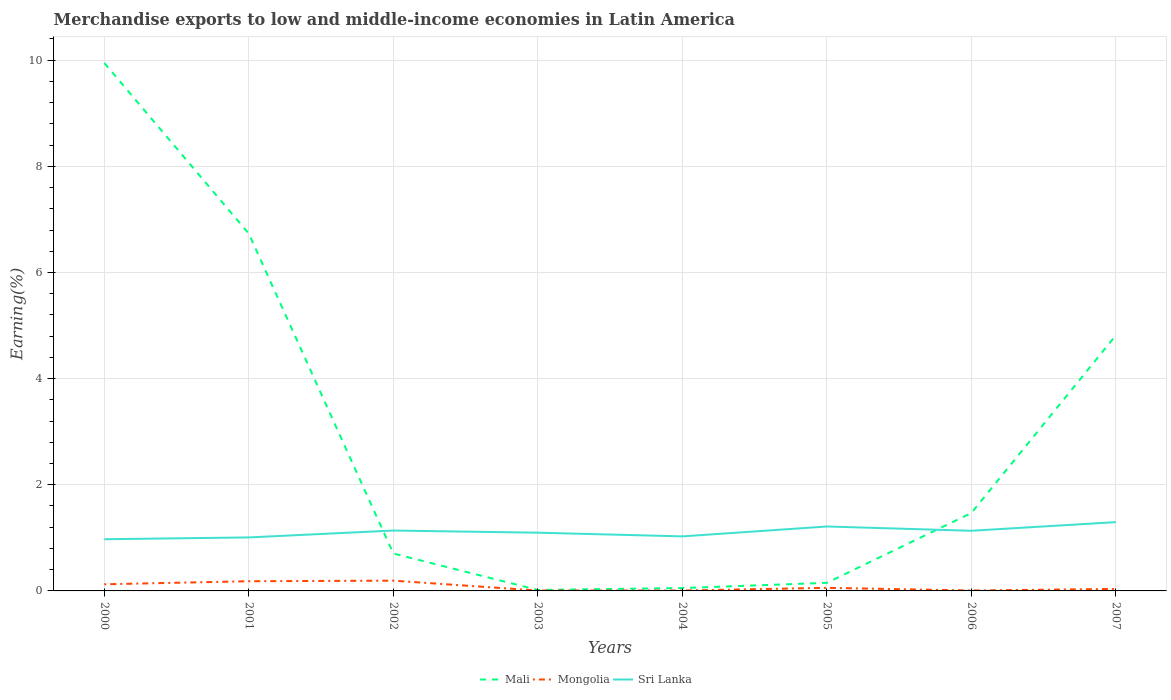How many different coloured lines are there?
Ensure brevity in your answer.  3. Does the line corresponding to Mali intersect with the line corresponding to Mongolia?
Provide a succinct answer. No. Is the number of lines equal to the number of legend labels?
Provide a succinct answer. Yes. Across all years, what is the maximum percentage of amount earned from merchandise exports in Sri Lanka?
Offer a terse response. 0.97. What is the total percentage of amount earned from merchandise exports in Mali in the graph?
Offer a very short reply. 3.22. What is the difference between the highest and the second highest percentage of amount earned from merchandise exports in Mongolia?
Provide a short and direct response. 0.19. Is the percentage of amount earned from merchandise exports in Mongolia strictly greater than the percentage of amount earned from merchandise exports in Sri Lanka over the years?
Your answer should be very brief. Yes. How many years are there in the graph?
Ensure brevity in your answer.  8. What is the difference between two consecutive major ticks on the Y-axis?
Provide a short and direct response. 2. Does the graph contain any zero values?
Give a very brief answer. No. How many legend labels are there?
Make the answer very short. 3. What is the title of the graph?
Your answer should be compact. Merchandise exports to low and middle-income economies in Latin America. What is the label or title of the Y-axis?
Offer a very short reply. Earning(%). What is the Earning(%) of Mali in 2000?
Provide a succinct answer. 9.95. What is the Earning(%) in Mongolia in 2000?
Your answer should be very brief. 0.13. What is the Earning(%) in Sri Lanka in 2000?
Your answer should be very brief. 0.97. What is the Earning(%) in Mali in 2001?
Your answer should be compact. 6.73. What is the Earning(%) in Mongolia in 2001?
Provide a short and direct response. 0.18. What is the Earning(%) of Sri Lanka in 2001?
Provide a short and direct response. 1.01. What is the Earning(%) of Mali in 2002?
Ensure brevity in your answer.  0.7. What is the Earning(%) of Mongolia in 2002?
Offer a very short reply. 0.19. What is the Earning(%) of Sri Lanka in 2002?
Your response must be concise. 1.14. What is the Earning(%) of Mali in 2003?
Provide a short and direct response. 0.02. What is the Earning(%) of Mongolia in 2003?
Offer a very short reply. 0.01. What is the Earning(%) of Sri Lanka in 2003?
Make the answer very short. 1.1. What is the Earning(%) in Mali in 2004?
Keep it short and to the point. 0.05. What is the Earning(%) in Mongolia in 2004?
Ensure brevity in your answer.  0.01. What is the Earning(%) of Sri Lanka in 2004?
Keep it short and to the point. 1.03. What is the Earning(%) of Mali in 2005?
Make the answer very short. 0.15. What is the Earning(%) of Mongolia in 2005?
Your answer should be very brief. 0.06. What is the Earning(%) of Sri Lanka in 2005?
Give a very brief answer. 1.21. What is the Earning(%) in Mali in 2006?
Keep it short and to the point. 1.47. What is the Earning(%) of Mongolia in 2006?
Your answer should be very brief. 0.01. What is the Earning(%) of Sri Lanka in 2006?
Give a very brief answer. 1.13. What is the Earning(%) of Mali in 2007?
Offer a terse response. 4.82. What is the Earning(%) in Mongolia in 2007?
Make the answer very short. 0.04. What is the Earning(%) of Sri Lanka in 2007?
Provide a succinct answer. 1.3. Across all years, what is the maximum Earning(%) in Mali?
Make the answer very short. 9.95. Across all years, what is the maximum Earning(%) of Mongolia?
Ensure brevity in your answer.  0.19. Across all years, what is the maximum Earning(%) in Sri Lanka?
Offer a very short reply. 1.3. Across all years, what is the minimum Earning(%) of Mali?
Your response must be concise. 0.02. Across all years, what is the minimum Earning(%) in Mongolia?
Your answer should be compact. 0.01. Across all years, what is the minimum Earning(%) of Sri Lanka?
Keep it short and to the point. 0.97. What is the total Earning(%) in Mali in the graph?
Your answer should be very brief. 23.89. What is the total Earning(%) in Mongolia in the graph?
Give a very brief answer. 0.62. What is the total Earning(%) of Sri Lanka in the graph?
Ensure brevity in your answer.  8.89. What is the difference between the Earning(%) in Mali in 2000 and that in 2001?
Your answer should be compact. 3.22. What is the difference between the Earning(%) of Mongolia in 2000 and that in 2001?
Your answer should be compact. -0.06. What is the difference between the Earning(%) of Sri Lanka in 2000 and that in 2001?
Ensure brevity in your answer.  -0.03. What is the difference between the Earning(%) in Mali in 2000 and that in 2002?
Your answer should be very brief. 9.24. What is the difference between the Earning(%) in Mongolia in 2000 and that in 2002?
Ensure brevity in your answer.  -0.07. What is the difference between the Earning(%) in Sri Lanka in 2000 and that in 2002?
Offer a terse response. -0.16. What is the difference between the Earning(%) in Mali in 2000 and that in 2003?
Offer a terse response. 9.93. What is the difference between the Earning(%) in Mongolia in 2000 and that in 2003?
Ensure brevity in your answer.  0.12. What is the difference between the Earning(%) in Sri Lanka in 2000 and that in 2003?
Keep it short and to the point. -0.12. What is the difference between the Earning(%) of Mali in 2000 and that in 2004?
Your response must be concise. 9.89. What is the difference between the Earning(%) of Mongolia in 2000 and that in 2004?
Keep it short and to the point. 0.12. What is the difference between the Earning(%) of Sri Lanka in 2000 and that in 2004?
Offer a terse response. -0.05. What is the difference between the Earning(%) in Mali in 2000 and that in 2005?
Make the answer very short. 9.79. What is the difference between the Earning(%) in Mongolia in 2000 and that in 2005?
Provide a succinct answer. 0.07. What is the difference between the Earning(%) in Sri Lanka in 2000 and that in 2005?
Provide a short and direct response. -0.24. What is the difference between the Earning(%) of Mali in 2000 and that in 2006?
Ensure brevity in your answer.  8.48. What is the difference between the Earning(%) of Mongolia in 2000 and that in 2006?
Your answer should be very brief. 0.12. What is the difference between the Earning(%) of Sri Lanka in 2000 and that in 2006?
Provide a short and direct response. -0.16. What is the difference between the Earning(%) of Mali in 2000 and that in 2007?
Ensure brevity in your answer.  5.13. What is the difference between the Earning(%) in Mongolia in 2000 and that in 2007?
Provide a short and direct response. 0.09. What is the difference between the Earning(%) of Sri Lanka in 2000 and that in 2007?
Your response must be concise. -0.32. What is the difference between the Earning(%) of Mali in 2001 and that in 2002?
Your answer should be compact. 6.03. What is the difference between the Earning(%) of Mongolia in 2001 and that in 2002?
Offer a very short reply. -0.01. What is the difference between the Earning(%) of Sri Lanka in 2001 and that in 2002?
Offer a terse response. -0.13. What is the difference between the Earning(%) in Mali in 2001 and that in 2003?
Offer a terse response. 6.71. What is the difference between the Earning(%) in Mongolia in 2001 and that in 2003?
Offer a very short reply. 0.18. What is the difference between the Earning(%) of Sri Lanka in 2001 and that in 2003?
Your answer should be compact. -0.09. What is the difference between the Earning(%) of Mali in 2001 and that in 2004?
Your answer should be very brief. 6.68. What is the difference between the Earning(%) of Mongolia in 2001 and that in 2004?
Ensure brevity in your answer.  0.17. What is the difference between the Earning(%) in Sri Lanka in 2001 and that in 2004?
Provide a succinct answer. -0.02. What is the difference between the Earning(%) of Mali in 2001 and that in 2005?
Offer a terse response. 6.58. What is the difference between the Earning(%) in Mongolia in 2001 and that in 2005?
Give a very brief answer. 0.12. What is the difference between the Earning(%) of Sri Lanka in 2001 and that in 2005?
Offer a terse response. -0.21. What is the difference between the Earning(%) of Mali in 2001 and that in 2006?
Make the answer very short. 5.26. What is the difference between the Earning(%) of Mongolia in 2001 and that in 2006?
Provide a short and direct response. 0.17. What is the difference between the Earning(%) of Sri Lanka in 2001 and that in 2006?
Your answer should be compact. -0.13. What is the difference between the Earning(%) of Mali in 2001 and that in 2007?
Your answer should be compact. 1.92. What is the difference between the Earning(%) in Mongolia in 2001 and that in 2007?
Provide a succinct answer. 0.15. What is the difference between the Earning(%) in Sri Lanka in 2001 and that in 2007?
Ensure brevity in your answer.  -0.29. What is the difference between the Earning(%) of Mali in 2002 and that in 2003?
Keep it short and to the point. 0.69. What is the difference between the Earning(%) in Mongolia in 2002 and that in 2003?
Your answer should be compact. 0.19. What is the difference between the Earning(%) in Sri Lanka in 2002 and that in 2003?
Your response must be concise. 0.04. What is the difference between the Earning(%) of Mali in 2002 and that in 2004?
Make the answer very short. 0.65. What is the difference between the Earning(%) in Mongolia in 2002 and that in 2004?
Your answer should be very brief. 0.19. What is the difference between the Earning(%) of Sri Lanka in 2002 and that in 2004?
Your response must be concise. 0.11. What is the difference between the Earning(%) of Mali in 2002 and that in 2005?
Make the answer very short. 0.55. What is the difference between the Earning(%) of Mongolia in 2002 and that in 2005?
Give a very brief answer. 0.14. What is the difference between the Earning(%) in Sri Lanka in 2002 and that in 2005?
Your answer should be very brief. -0.08. What is the difference between the Earning(%) of Mali in 2002 and that in 2006?
Your answer should be very brief. -0.76. What is the difference between the Earning(%) in Mongolia in 2002 and that in 2006?
Provide a succinct answer. 0.19. What is the difference between the Earning(%) in Sri Lanka in 2002 and that in 2006?
Offer a very short reply. 0. What is the difference between the Earning(%) of Mali in 2002 and that in 2007?
Ensure brevity in your answer.  -4.11. What is the difference between the Earning(%) of Mongolia in 2002 and that in 2007?
Your response must be concise. 0.16. What is the difference between the Earning(%) of Sri Lanka in 2002 and that in 2007?
Provide a short and direct response. -0.16. What is the difference between the Earning(%) in Mali in 2003 and that in 2004?
Keep it short and to the point. -0.04. What is the difference between the Earning(%) of Mongolia in 2003 and that in 2004?
Give a very brief answer. -0. What is the difference between the Earning(%) of Sri Lanka in 2003 and that in 2004?
Ensure brevity in your answer.  0.07. What is the difference between the Earning(%) of Mali in 2003 and that in 2005?
Keep it short and to the point. -0.13. What is the difference between the Earning(%) of Mongolia in 2003 and that in 2005?
Give a very brief answer. -0.05. What is the difference between the Earning(%) of Sri Lanka in 2003 and that in 2005?
Make the answer very short. -0.12. What is the difference between the Earning(%) in Mali in 2003 and that in 2006?
Give a very brief answer. -1.45. What is the difference between the Earning(%) in Mongolia in 2003 and that in 2006?
Your answer should be very brief. -0. What is the difference between the Earning(%) of Sri Lanka in 2003 and that in 2006?
Your response must be concise. -0.04. What is the difference between the Earning(%) of Mali in 2003 and that in 2007?
Provide a succinct answer. -4.8. What is the difference between the Earning(%) of Mongolia in 2003 and that in 2007?
Provide a short and direct response. -0.03. What is the difference between the Earning(%) of Sri Lanka in 2003 and that in 2007?
Keep it short and to the point. -0.2. What is the difference between the Earning(%) of Mali in 2004 and that in 2005?
Your response must be concise. -0.1. What is the difference between the Earning(%) in Mongolia in 2004 and that in 2005?
Give a very brief answer. -0.05. What is the difference between the Earning(%) of Sri Lanka in 2004 and that in 2005?
Provide a succinct answer. -0.19. What is the difference between the Earning(%) of Mali in 2004 and that in 2006?
Your answer should be compact. -1.41. What is the difference between the Earning(%) in Mongolia in 2004 and that in 2006?
Offer a very short reply. -0. What is the difference between the Earning(%) in Sri Lanka in 2004 and that in 2006?
Offer a very short reply. -0.11. What is the difference between the Earning(%) of Mali in 2004 and that in 2007?
Provide a short and direct response. -4.76. What is the difference between the Earning(%) in Mongolia in 2004 and that in 2007?
Offer a terse response. -0.03. What is the difference between the Earning(%) in Sri Lanka in 2004 and that in 2007?
Keep it short and to the point. -0.27. What is the difference between the Earning(%) in Mali in 2005 and that in 2006?
Provide a short and direct response. -1.32. What is the difference between the Earning(%) in Mongolia in 2005 and that in 2006?
Provide a short and direct response. 0.05. What is the difference between the Earning(%) of Sri Lanka in 2005 and that in 2006?
Offer a terse response. 0.08. What is the difference between the Earning(%) in Mali in 2005 and that in 2007?
Your answer should be very brief. -4.66. What is the difference between the Earning(%) in Mongolia in 2005 and that in 2007?
Your answer should be compact. 0.02. What is the difference between the Earning(%) in Sri Lanka in 2005 and that in 2007?
Your answer should be compact. -0.08. What is the difference between the Earning(%) of Mali in 2006 and that in 2007?
Your response must be concise. -3.35. What is the difference between the Earning(%) of Mongolia in 2006 and that in 2007?
Provide a short and direct response. -0.03. What is the difference between the Earning(%) of Sri Lanka in 2006 and that in 2007?
Provide a succinct answer. -0.16. What is the difference between the Earning(%) in Mali in 2000 and the Earning(%) in Mongolia in 2001?
Your answer should be very brief. 9.76. What is the difference between the Earning(%) of Mali in 2000 and the Earning(%) of Sri Lanka in 2001?
Your response must be concise. 8.94. What is the difference between the Earning(%) in Mongolia in 2000 and the Earning(%) in Sri Lanka in 2001?
Your answer should be compact. -0.88. What is the difference between the Earning(%) in Mali in 2000 and the Earning(%) in Mongolia in 2002?
Keep it short and to the point. 9.75. What is the difference between the Earning(%) in Mali in 2000 and the Earning(%) in Sri Lanka in 2002?
Ensure brevity in your answer.  8.81. What is the difference between the Earning(%) in Mongolia in 2000 and the Earning(%) in Sri Lanka in 2002?
Provide a succinct answer. -1.01. What is the difference between the Earning(%) of Mali in 2000 and the Earning(%) of Mongolia in 2003?
Provide a short and direct response. 9.94. What is the difference between the Earning(%) in Mali in 2000 and the Earning(%) in Sri Lanka in 2003?
Provide a succinct answer. 8.85. What is the difference between the Earning(%) of Mongolia in 2000 and the Earning(%) of Sri Lanka in 2003?
Ensure brevity in your answer.  -0.97. What is the difference between the Earning(%) in Mali in 2000 and the Earning(%) in Mongolia in 2004?
Your answer should be very brief. 9.94. What is the difference between the Earning(%) of Mali in 2000 and the Earning(%) of Sri Lanka in 2004?
Give a very brief answer. 8.92. What is the difference between the Earning(%) in Mongolia in 2000 and the Earning(%) in Sri Lanka in 2004?
Ensure brevity in your answer.  -0.9. What is the difference between the Earning(%) in Mali in 2000 and the Earning(%) in Mongolia in 2005?
Your response must be concise. 9.89. What is the difference between the Earning(%) in Mali in 2000 and the Earning(%) in Sri Lanka in 2005?
Keep it short and to the point. 8.73. What is the difference between the Earning(%) of Mongolia in 2000 and the Earning(%) of Sri Lanka in 2005?
Provide a short and direct response. -1.09. What is the difference between the Earning(%) in Mali in 2000 and the Earning(%) in Mongolia in 2006?
Offer a terse response. 9.94. What is the difference between the Earning(%) of Mali in 2000 and the Earning(%) of Sri Lanka in 2006?
Your response must be concise. 8.81. What is the difference between the Earning(%) of Mongolia in 2000 and the Earning(%) of Sri Lanka in 2006?
Offer a terse response. -1.01. What is the difference between the Earning(%) of Mali in 2000 and the Earning(%) of Mongolia in 2007?
Provide a short and direct response. 9.91. What is the difference between the Earning(%) of Mali in 2000 and the Earning(%) of Sri Lanka in 2007?
Provide a short and direct response. 8.65. What is the difference between the Earning(%) in Mongolia in 2000 and the Earning(%) in Sri Lanka in 2007?
Provide a short and direct response. -1.17. What is the difference between the Earning(%) of Mali in 2001 and the Earning(%) of Mongolia in 2002?
Provide a short and direct response. 6.54. What is the difference between the Earning(%) of Mali in 2001 and the Earning(%) of Sri Lanka in 2002?
Give a very brief answer. 5.59. What is the difference between the Earning(%) in Mongolia in 2001 and the Earning(%) in Sri Lanka in 2002?
Ensure brevity in your answer.  -0.95. What is the difference between the Earning(%) of Mali in 2001 and the Earning(%) of Mongolia in 2003?
Your answer should be compact. 6.72. What is the difference between the Earning(%) of Mali in 2001 and the Earning(%) of Sri Lanka in 2003?
Offer a very short reply. 5.63. What is the difference between the Earning(%) in Mongolia in 2001 and the Earning(%) in Sri Lanka in 2003?
Ensure brevity in your answer.  -0.91. What is the difference between the Earning(%) of Mali in 2001 and the Earning(%) of Mongolia in 2004?
Ensure brevity in your answer.  6.72. What is the difference between the Earning(%) in Mali in 2001 and the Earning(%) in Sri Lanka in 2004?
Give a very brief answer. 5.7. What is the difference between the Earning(%) in Mongolia in 2001 and the Earning(%) in Sri Lanka in 2004?
Offer a terse response. -0.84. What is the difference between the Earning(%) in Mali in 2001 and the Earning(%) in Mongolia in 2005?
Offer a very short reply. 6.67. What is the difference between the Earning(%) of Mali in 2001 and the Earning(%) of Sri Lanka in 2005?
Your answer should be compact. 5.52. What is the difference between the Earning(%) of Mongolia in 2001 and the Earning(%) of Sri Lanka in 2005?
Your response must be concise. -1.03. What is the difference between the Earning(%) of Mali in 2001 and the Earning(%) of Mongolia in 2006?
Give a very brief answer. 6.72. What is the difference between the Earning(%) of Mali in 2001 and the Earning(%) of Sri Lanka in 2006?
Provide a succinct answer. 5.6. What is the difference between the Earning(%) in Mongolia in 2001 and the Earning(%) in Sri Lanka in 2006?
Offer a terse response. -0.95. What is the difference between the Earning(%) of Mali in 2001 and the Earning(%) of Mongolia in 2007?
Make the answer very short. 6.69. What is the difference between the Earning(%) in Mali in 2001 and the Earning(%) in Sri Lanka in 2007?
Make the answer very short. 5.44. What is the difference between the Earning(%) in Mongolia in 2001 and the Earning(%) in Sri Lanka in 2007?
Provide a short and direct response. -1.11. What is the difference between the Earning(%) of Mali in 2002 and the Earning(%) of Mongolia in 2003?
Make the answer very short. 0.7. What is the difference between the Earning(%) in Mali in 2002 and the Earning(%) in Sri Lanka in 2003?
Your answer should be very brief. -0.39. What is the difference between the Earning(%) of Mongolia in 2002 and the Earning(%) of Sri Lanka in 2003?
Provide a short and direct response. -0.9. What is the difference between the Earning(%) in Mali in 2002 and the Earning(%) in Mongolia in 2004?
Provide a short and direct response. 0.7. What is the difference between the Earning(%) of Mali in 2002 and the Earning(%) of Sri Lanka in 2004?
Give a very brief answer. -0.32. What is the difference between the Earning(%) in Mongolia in 2002 and the Earning(%) in Sri Lanka in 2004?
Offer a very short reply. -0.83. What is the difference between the Earning(%) in Mali in 2002 and the Earning(%) in Mongolia in 2005?
Make the answer very short. 0.65. What is the difference between the Earning(%) in Mali in 2002 and the Earning(%) in Sri Lanka in 2005?
Make the answer very short. -0.51. What is the difference between the Earning(%) in Mongolia in 2002 and the Earning(%) in Sri Lanka in 2005?
Give a very brief answer. -1.02. What is the difference between the Earning(%) of Mali in 2002 and the Earning(%) of Mongolia in 2006?
Offer a terse response. 0.7. What is the difference between the Earning(%) of Mali in 2002 and the Earning(%) of Sri Lanka in 2006?
Keep it short and to the point. -0.43. What is the difference between the Earning(%) in Mongolia in 2002 and the Earning(%) in Sri Lanka in 2006?
Offer a very short reply. -0.94. What is the difference between the Earning(%) of Mali in 2002 and the Earning(%) of Mongolia in 2007?
Offer a terse response. 0.67. What is the difference between the Earning(%) in Mali in 2002 and the Earning(%) in Sri Lanka in 2007?
Offer a very short reply. -0.59. What is the difference between the Earning(%) in Mongolia in 2002 and the Earning(%) in Sri Lanka in 2007?
Make the answer very short. -1.1. What is the difference between the Earning(%) in Mali in 2003 and the Earning(%) in Mongolia in 2004?
Make the answer very short. 0.01. What is the difference between the Earning(%) of Mali in 2003 and the Earning(%) of Sri Lanka in 2004?
Your answer should be compact. -1.01. What is the difference between the Earning(%) of Mongolia in 2003 and the Earning(%) of Sri Lanka in 2004?
Your response must be concise. -1.02. What is the difference between the Earning(%) of Mali in 2003 and the Earning(%) of Mongolia in 2005?
Provide a succinct answer. -0.04. What is the difference between the Earning(%) in Mali in 2003 and the Earning(%) in Sri Lanka in 2005?
Your answer should be very brief. -1.2. What is the difference between the Earning(%) in Mongolia in 2003 and the Earning(%) in Sri Lanka in 2005?
Ensure brevity in your answer.  -1.21. What is the difference between the Earning(%) of Mali in 2003 and the Earning(%) of Mongolia in 2006?
Give a very brief answer. 0.01. What is the difference between the Earning(%) in Mali in 2003 and the Earning(%) in Sri Lanka in 2006?
Make the answer very short. -1.12. What is the difference between the Earning(%) in Mongolia in 2003 and the Earning(%) in Sri Lanka in 2006?
Make the answer very short. -1.13. What is the difference between the Earning(%) of Mali in 2003 and the Earning(%) of Mongolia in 2007?
Your response must be concise. -0.02. What is the difference between the Earning(%) of Mali in 2003 and the Earning(%) of Sri Lanka in 2007?
Provide a succinct answer. -1.28. What is the difference between the Earning(%) of Mongolia in 2003 and the Earning(%) of Sri Lanka in 2007?
Keep it short and to the point. -1.29. What is the difference between the Earning(%) in Mali in 2004 and the Earning(%) in Mongolia in 2005?
Give a very brief answer. -0. What is the difference between the Earning(%) of Mali in 2004 and the Earning(%) of Sri Lanka in 2005?
Make the answer very short. -1.16. What is the difference between the Earning(%) in Mongolia in 2004 and the Earning(%) in Sri Lanka in 2005?
Offer a terse response. -1.21. What is the difference between the Earning(%) of Mali in 2004 and the Earning(%) of Mongolia in 2006?
Provide a succinct answer. 0.05. What is the difference between the Earning(%) of Mali in 2004 and the Earning(%) of Sri Lanka in 2006?
Provide a short and direct response. -1.08. What is the difference between the Earning(%) in Mongolia in 2004 and the Earning(%) in Sri Lanka in 2006?
Provide a short and direct response. -1.13. What is the difference between the Earning(%) in Mali in 2004 and the Earning(%) in Mongolia in 2007?
Your answer should be compact. 0.02. What is the difference between the Earning(%) in Mali in 2004 and the Earning(%) in Sri Lanka in 2007?
Your answer should be compact. -1.24. What is the difference between the Earning(%) in Mongolia in 2004 and the Earning(%) in Sri Lanka in 2007?
Your response must be concise. -1.29. What is the difference between the Earning(%) in Mali in 2005 and the Earning(%) in Mongolia in 2006?
Give a very brief answer. 0.14. What is the difference between the Earning(%) in Mali in 2005 and the Earning(%) in Sri Lanka in 2006?
Your answer should be very brief. -0.98. What is the difference between the Earning(%) in Mongolia in 2005 and the Earning(%) in Sri Lanka in 2006?
Offer a very short reply. -1.08. What is the difference between the Earning(%) in Mali in 2005 and the Earning(%) in Mongolia in 2007?
Offer a very short reply. 0.12. What is the difference between the Earning(%) in Mali in 2005 and the Earning(%) in Sri Lanka in 2007?
Give a very brief answer. -1.14. What is the difference between the Earning(%) of Mongolia in 2005 and the Earning(%) of Sri Lanka in 2007?
Provide a succinct answer. -1.24. What is the difference between the Earning(%) in Mali in 2006 and the Earning(%) in Mongolia in 2007?
Provide a short and direct response. 1.43. What is the difference between the Earning(%) in Mali in 2006 and the Earning(%) in Sri Lanka in 2007?
Your answer should be compact. 0.17. What is the difference between the Earning(%) of Mongolia in 2006 and the Earning(%) of Sri Lanka in 2007?
Give a very brief answer. -1.29. What is the average Earning(%) in Mali per year?
Keep it short and to the point. 2.99. What is the average Earning(%) of Mongolia per year?
Make the answer very short. 0.08. What is the average Earning(%) of Sri Lanka per year?
Offer a terse response. 1.11. In the year 2000, what is the difference between the Earning(%) in Mali and Earning(%) in Mongolia?
Your answer should be very brief. 9.82. In the year 2000, what is the difference between the Earning(%) in Mali and Earning(%) in Sri Lanka?
Your response must be concise. 8.97. In the year 2000, what is the difference between the Earning(%) in Mongolia and Earning(%) in Sri Lanka?
Your response must be concise. -0.85. In the year 2001, what is the difference between the Earning(%) in Mali and Earning(%) in Mongolia?
Ensure brevity in your answer.  6.55. In the year 2001, what is the difference between the Earning(%) in Mali and Earning(%) in Sri Lanka?
Keep it short and to the point. 5.72. In the year 2001, what is the difference between the Earning(%) in Mongolia and Earning(%) in Sri Lanka?
Your answer should be compact. -0.83. In the year 2002, what is the difference between the Earning(%) in Mali and Earning(%) in Mongolia?
Provide a succinct answer. 0.51. In the year 2002, what is the difference between the Earning(%) in Mali and Earning(%) in Sri Lanka?
Provide a succinct answer. -0.43. In the year 2002, what is the difference between the Earning(%) in Mongolia and Earning(%) in Sri Lanka?
Provide a succinct answer. -0.94. In the year 2003, what is the difference between the Earning(%) in Mali and Earning(%) in Mongolia?
Give a very brief answer. 0.01. In the year 2003, what is the difference between the Earning(%) of Mali and Earning(%) of Sri Lanka?
Ensure brevity in your answer.  -1.08. In the year 2003, what is the difference between the Earning(%) in Mongolia and Earning(%) in Sri Lanka?
Ensure brevity in your answer.  -1.09. In the year 2004, what is the difference between the Earning(%) in Mali and Earning(%) in Mongolia?
Provide a short and direct response. 0.05. In the year 2004, what is the difference between the Earning(%) of Mali and Earning(%) of Sri Lanka?
Give a very brief answer. -0.97. In the year 2004, what is the difference between the Earning(%) in Mongolia and Earning(%) in Sri Lanka?
Your response must be concise. -1.02. In the year 2005, what is the difference between the Earning(%) in Mali and Earning(%) in Mongolia?
Provide a succinct answer. 0.09. In the year 2005, what is the difference between the Earning(%) in Mali and Earning(%) in Sri Lanka?
Offer a terse response. -1.06. In the year 2005, what is the difference between the Earning(%) in Mongolia and Earning(%) in Sri Lanka?
Your answer should be compact. -1.16. In the year 2006, what is the difference between the Earning(%) of Mali and Earning(%) of Mongolia?
Your answer should be compact. 1.46. In the year 2006, what is the difference between the Earning(%) of Mali and Earning(%) of Sri Lanka?
Make the answer very short. 0.34. In the year 2006, what is the difference between the Earning(%) of Mongolia and Earning(%) of Sri Lanka?
Give a very brief answer. -1.13. In the year 2007, what is the difference between the Earning(%) of Mali and Earning(%) of Mongolia?
Give a very brief answer. 4.78. In the year 2007, what is the difference between the Earning(%) of Mali and Earning(%) of Sri Lanka?
Offer a very short reply. 3.52. In the year 2007, what is the difference between the Earning(%) in Mongolia and Earning(%) in Sri Lanka?
Ensure brevity in your answer.  -1.26. What is the ratio of the Earning(%) of Mali in 2000 to that in 2001?
Your response must be concise. 1.48. What is the ratio of the Earning(%) in Mongolia in 2000 to that in 2001?
Offer a very short reply. 0.68. What is the ratio of the Earning(%) of Sri Lanka in 2000 to that in 2001?
Provide a succinct answer. 0.97. What is the ratio of the Earning(%) in Mali in 2000 to that in 2002?
Provide a succinct answer. 14.12. What is the ratio of the Earning(%) of Mongolia in 2000 to that in 2002?
Provide a succinct answer. 0.65. What is the ratio of the Earning(%) in Sri Lanka in 2000 to that in 2002?
Ensure brevity in your answer.  0.86. What is the ratio of the Earning(%) in Mali in 2000 to that in 2003?
Provide a succinct answer. 554.47. What is the ratio of the Earning(%) of Mongolia in 2000 to that in 2003?
Your answer should be very brief. 18.28. What is the ratio of the Earning(%) of Sri Lanka in 2000 to that in 2003?
Give a very brief answer. 0.89. What is the ratio of the Earning(%) of Mali in 2000 to that in 2004?
Offer a terse response. 183.79. What is the ratio of the Earning(%) in Mongolia in 2000 to that in 2004?
Your answer should be compact. 16.57. What is the ratio of the Earning(%) of Sri Lanka in 2000 to that in 2004?
Make the answer very short. 0.95. What is the ratio of the Earning(%) of Mali in 2000 to that in 2005?
Your answer should be very brief. 65.14. What is the ratio of the Earning(%) of Mongolia in 2000 to that in 2005?
Your response must be concise. 2.16. What is the ratio of the Earning(%) of Sri Lanka in 2000 to that in 2005?
Your response must be concise. 0.8. What is the ratio of the Earning(%) in Mali in 2000 to that in 2006?
Provide a succinct answer. 6.77. What is the ratio of the Earning(%) in Mongolia in 2000 to that in 2006?
Provide a succinct answer. 15.59. What is the ratio of the Earning(%) in Sri Lanka in 2000 to that in 2006?
Your response must be concise. 0.86. What is the ratio of the Earning(%) of Mali in 2000 to that in 2007?
Your response must be concise. 2.07. What is the ratio of the Earning(%) in Mongolia in 2000 to that in 2007?
Offer a very short reply. 3.33. What is the ratio of the Earning(%) in Sri Lanka in 2000 to that in 2007?
Provide a short and direct response. 0.75. What is the ratio of the Earning(%) in Mali in 2001 to that in 2002?
Provide a succinct answer. 9.56. What is the ratio of the Earning(%) of Mongolia in 2001 to that in 2002?
Make the answer very short. 0.94. What is the ratio of the Earning(%) of Sri Lanka in 2001 to that in 2002?
Provide a succinct answer. 0.89. What is the ratio of the Earning(%) in Mali in 2001 to that in 2003?
Keep it short and to the point. 375.23. What is the ratio of the Earning(%) of Mongolia in 2001 to that in 2003?
Offer a very short reply. 26.68. What is the ratio of the Earning(%) of Sri Lanka in 2001 to that in 2003?
Offer a terse response. 0.92. What is the ratio of the Earning(%) of Mali in 2001 to that in 2004?
Ensure brevity in your answer.  124.38. What is the ratio of the Earning(%) of Mongolia in 2001 to that in 2004?
Offer a very short reply. 24.19. What is the ratio of the Earning(%) in Sri Lanka in 2001 to that in 2004?
Your response must be concise. 0.98. What is the ratio of the Earning(%) of Mali in 2001 to that in 2005?
Provide a succinct answer. 44.08. What is the ratio of the Earning(%) in Mongolia in 2001 to that in 2005?
Provide a succinct answer. 3.15. What is the ratio of the Earning(%) of Sri Lanka in 2001 to that in 2005?
Your answer should be compact. 0.83. What is the ratio of the Earning(%) in Mali in 2001 to that in 2006?
Keep it short and to the point. 4.58. What is the ratio of the Earning(%) in Mongolia in 2001 to that in 2006?
Make the answer very short. 22.76. What is the ratio of the Earning(%) of Sri Lanka in 2001 to that in 2006?
Your answer should be very brief. 0.89. What is the ratio of the Earning(%) in Mali in 2001 to that in 2007?
Offer a very short reply. 1.4. What is the ratio of the Earning(%) in Mongolia in 2001 to that in 2007?
Your answer should be compact. 4.87. What is the ratio of the Earning(%) of Sri Lanka in 2001 to that in 2007?
Your answer should be very brief. 0.78. What is the ratio of the Earning(%) in Mali in 2002 to that in 2003?
Your answer should be compact. 39.27. What is the ratio of the Earning(%) in Mongolia in 2002 to that in 2003?
Your answer should be compact. 28.27. What is the ratio of the Earning(%) of Sri Lanka in 2002 to that in 2003?
Ensure brevity in your answer.  1.04. What is the ratio of the Earning(%) of Mali in 2002 to that in 2004?
Provide a succinct answer. 13.02. What is the ratio of the Earning(%) of Mongolia in 2002 to that in 2004?
Make the answer very short. 25.62. What is the ratio of the Earning(%) of Sri Lanka in 2002 to that in 2004?
Keep it short and to the point. 1.11. What is the ratio of the Earning(%) in Mali in 2002 to that in 2005?
Offer a terse response. 4.61. What is the ratio of the Earning(%) in Mongolia in 2002 to that in 2005?
Your response must be concise. 3.34. What is the ratio of the Earning(%) of Sri Lanka in 2002 to that in 2005?
Give a very brief answer. 0.94. What is the ratio of the Earning(%) in Mali in 2002 to that in 2006?
Provide a succinct answer. 0.48. What is the ratio of the Earning(%) of Mongolia in 2002 to that in 2006?
Give a very brief answer. 24.11. What is the ratio of the Earning(%) of Sri Lanka in 2002 to that in 2006?
Keep it short and to the point. 1. What is the ratio of the Earning(%) in Mali in 2002 to that in 2007?
Give a very brief answer. 0.15. What is the ratio of the Earning(%) of Mongolia in 2002 to that in 2007?
Ensure brevity in your answer.  5.16. What is the ratio of the Earning(%) in Sri Lanka in 2002 to that in 2007?
Keep it short and to the point. 0.88. What is the ratio of the Earning(%) in Mali in 2003 to that in 2004?
Your response must be concise. 0.33. What is the ratio of the Earning(%) in Mongolia in 2003 to that in 2004?
Make the answer very short. 0.91. What is the ratio of the Earning(%) of Sri Lanka in 2003 to that in 2004?
Provide a succinct answer. 1.07. What is the ratio of the Earning(%) in Mali in 2003 to that in 2005?
Keep it short and to the point. 0.12. What is the ratio of the Earning(%) of Mongolia in 2003 to that in 2005?
Your response must be concise. 0.12. What is the ratio of the Earning(%) of Sri Lanka in 2003 to that in 2005?
Provide a short and direct response. 0.9. What is the ratio of the Earning(%) of Mali in 2003 to that in 2006?
Offer a terse response. 0.01. What is the ratio of the Earning(%) of Mongolia in 2003 to that in 2006?
Make the answer very short. 0.85. What is the ratio of the Earning(%) in Sri Lanka in 2003 to that in 2006?
Ensure brevity in your answer.  0.97. What is the ratio of the Earning(%) of Mali in 2003 to that in 2007?
Keep it short and to the point. 0. What is the ratio of the Earning(%) in Mongolia in 2003 to that in 2007?
Give a very brief answer. 0.18. What is the ratio of the Earning(%) of Sri Lanka in 2003 to that in 2007?
Give a very brief answer. 0.85. What is the ratio of the Earning(%) in Mali in 2004 to that in 2005?
Provide a succinct answer. 0.35. What is the ratio of the Earning(%) in Mongolia in 2004 to that in 2005?
Make the answer very short. 0.13. What is the ratio of the Earning(%) in Sri Lanka in 2004 to that in 2005?
Ensure brevity in your answer.  0.85. What is the ratio of the Earning(%) in Mali in 2004 to that in 2006?
Offer a terse response. 0.04. What is the ratio of the Earning(%) of Mongolia in 2004 to that in 2006?
Offer a terse response. 0.94. What is the ratio of the Earning(%) in Sri Lanka in 2004 to that in 2006?
Keep it short and to the point. 0.91. What is the ratio of the Earning(%) of Mali in 2004 to that in 2007?
Your response must be concise. 0.01. What is the ratio of the Earning(%) of Mongolia in 2004 to that in 2007?
Offer a very short reply. 0.2. What is the ratio of the Earning(%) in Sri Lanka in 2004 to that in 2007?
Your response must be concise. 0.79. What is the ratio of the Earning(%) of Mali in 2005 to that in 2006?
Give a very brief answer. 0.1. What is the ratio of the Earning(%) of Mongolia in 2005 to that in 2006?
Offer a very short reply. 7.23. What is the ratio of the Earning(%) of Sri Lanka in 2005 to that in 2006?
Make the answer very short. 1.07. What is the ratio of the Earning(%) in Mali in 2005 to that in 2007?
Keep it short and to the point. 0.03. What is the ratio of the Earning(%) in Mongolia in 2005 to that in 2007?
Your response must be concise. 1.55. What is the ratio of the Earning(%) of Sri Lanka in 2005 to that in 2007?
Offer a very short reply. 0.94. What is the ratio of the Earning(%) in Mali in 2006 to that in 2007?
Offer a very short reply. 0.3. What is the ratio of the Earning(%) in Mongolia in 2006 to that in 2007?
Provide a short and direct response. 0.21. What is the ratio of the Earning(%) in Sri Lanka in 2006 to that in 2007?
Your answer should be very brief. 0.87. What is the difference between the highest and the second highest Earning(%) in Mali?
Provide a short and direct response. 3.22. What is the difference between the highest and the second highest Earning(%) in Mongolia?
Your response must be concise. 0.01. What is the difference between the highest and the second highest Earning(%) of Sri Lanka?
Make the answer very short. 0.08. What is the difference between the highest and the lowest Earning(%) of Mali?
Your answer should be very brief. 9.93. What is the difference between the highest and the lowest Earning(%) in Mongolia?
Give a very brief answer. 0.19. What is the difference between the highest and the lowest Earning(%) in Sri Lanka?
Provide a succinct answer. 0.32. 